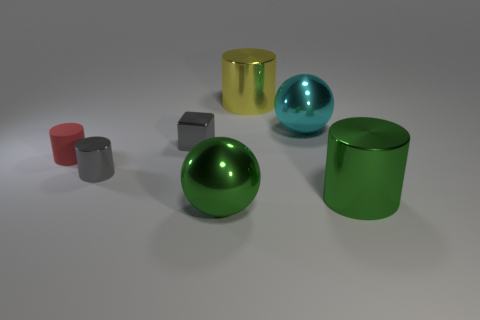What is the size of the thing that is the same color as the cube?
Provide a short and direct response. Small. Is there a tiny gray thing of the same shape as the tiny red rubber thing?
Your answer should be very brief. Yes. How many things are red rubber cylinders or tiny red matte cubes?
Your response must be concise. 1. What number of large cyan shiny spheres are to the left of the large ball in front of the big green metallic thing behind the large green sphere?
Ensure brevity in your answer.  0. What material is the small red thing that is the same shape as the large yellow shiny object?
Keep it short and to the point. Rubber. What material is the thing that is both to the right of the large yellow cylinder and left of the big green cylinder?
Offer a terse response. Metal. Is the number of red things that are behind the tiny cube less than the number of large metal spheres that are left of the cyan ball?
Give a very brief answer. Yes. What number of other objects are the same size as the green metal sphere?
Your answer should be very brief. 3. What is the shape of the big metallic object behind the metallic ball on the right side of the big green ball in front of the tiny matte cylinder?
Keep it short and to the point. Cylinder. How many red things are small rubber things or large shiny cylinders?
Give a very brief answer. 1. 